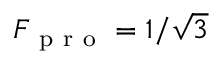<formula> <loc_0><loc_0><loc_500><loc_500>F _ { p r o } = 1 / \sqrt { 3 }</formula> 